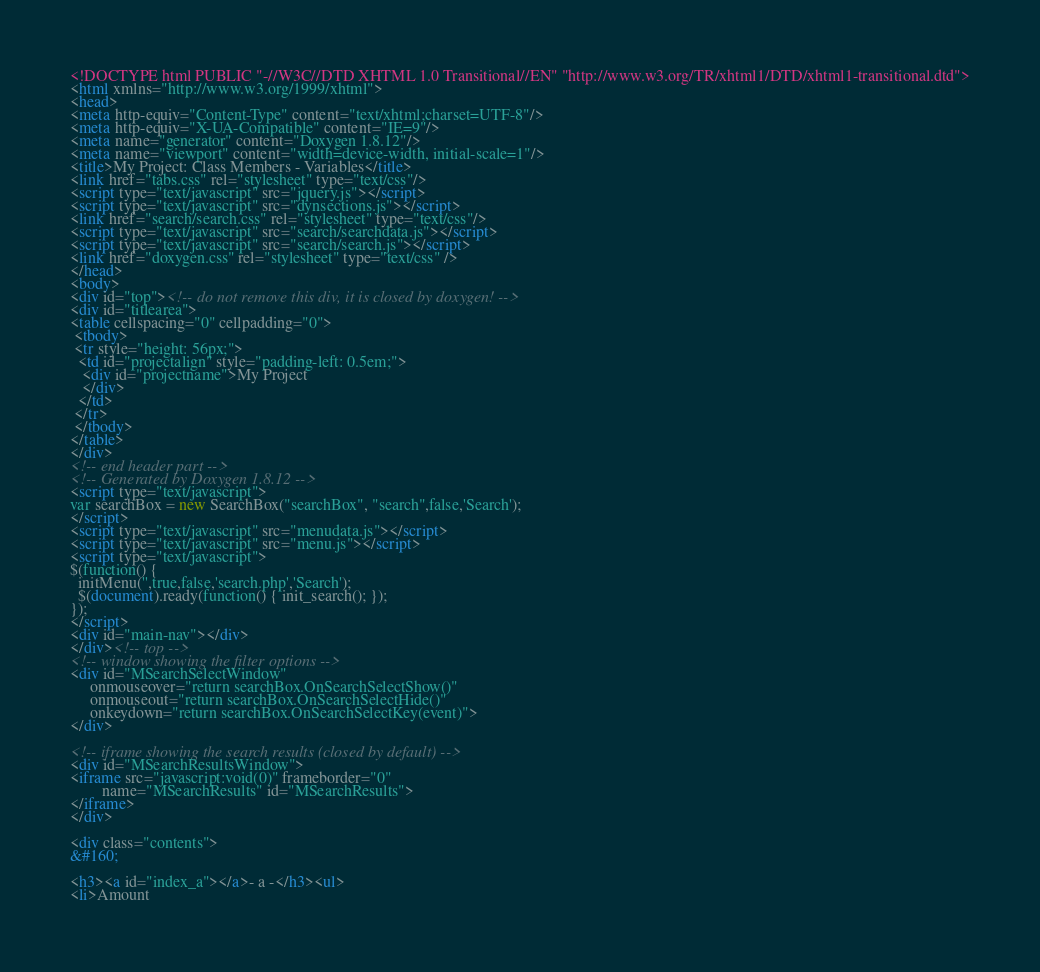<code> <loc_0><loc_0><loc_500><loc_500><_HTML_><!DOCTYPE html PUBLIC "-//W3C//DTD XHTML 1.0 Transitional//EN" "http://www.w3.org/TR/xhtml1/DTD/xhtml1-transitional.dtd">
<html xmlns="http://www.w3.org/1999/xhtml">
<head>
<meta http-equiv="Content-Type" content="text/xhtml;charset=UTF-8"/>
<meta http-equiv="X-UA-Compatible" content="IE=9"/>
<meta name="generator" content="Doxygen 1.8.12"/>
<meta name="viewport" content="width=device-width, initial-scale=1"/>
<title>My Project: Class Members - Variables</title>
<link href="tabs.css" rel="stylesheet" type="text/css"/>
<script type="text/javascript" src="jquery.js"></script>
<script type="text/javascript" src="dynsections.js"></script>
<link href="search/search.css" rel="stylesheet" type="text/css"/>
<script type="text/javascript" src="search/searchdata.js"></script>
<script type="text/javascript" src="search/search.js"></script>
<link href="doxygen.css" rel="stylesheet" type="text/css" />
</head>
<body>
<div id="top"><!-- do not remove this div, it is closed by doxygen! -->
<div id="titlearea">
<table cellspacing="0" cellpadding="0">
 <tbody>
 <tr style="height: 56px;">
  <td id="projectalign" style="padding-left: 0.5em;">
   <div id="projectname">My Project
   </div>
  </td>
 </tr>
 </tbody>
</table>
</div>
<!-- end header part -->
<!-- Generated by Doxygen 1.8.12 -->
<script type="text/javascript">
var searchBox = new SearchBox("searchBox", "search",false,'Search');
</script>
<script type="text/javascript" src="menudata.js"></script>
<script type="text/javascript" src="menu.js"></script>
<script type="text/javascript">
$(function() {
  initMenu('',true,false,'search.php','Search');
  $(document).ready(function() { init_search(); });
});
</script>
<div id="main-nav"></div>
</div><!-- top -->
<!-- window showing the filter options -->
<div id="MSearchSelectWindow"
     onmouseover="return searchBox.OnSearchSelectShow()"
     onmouseout="return searchBox.OnSearchSelectHide()"
     onkeydown="return searchBox.OnSearchSelectKey(event)">
</div>

<!-- iframe showing the search results (closed by default) -->
<div id="MSearchResultsWindow">
<iframe src="javascript:void(0)" frameborder="0" 
        name="MSearchResults" id="MSearchResults">
</iframe>
</div>

<div class="contents">
&#160;

<h3><a id="index_a"></a>- a -</h3><ul>
<li>Amount</code> 